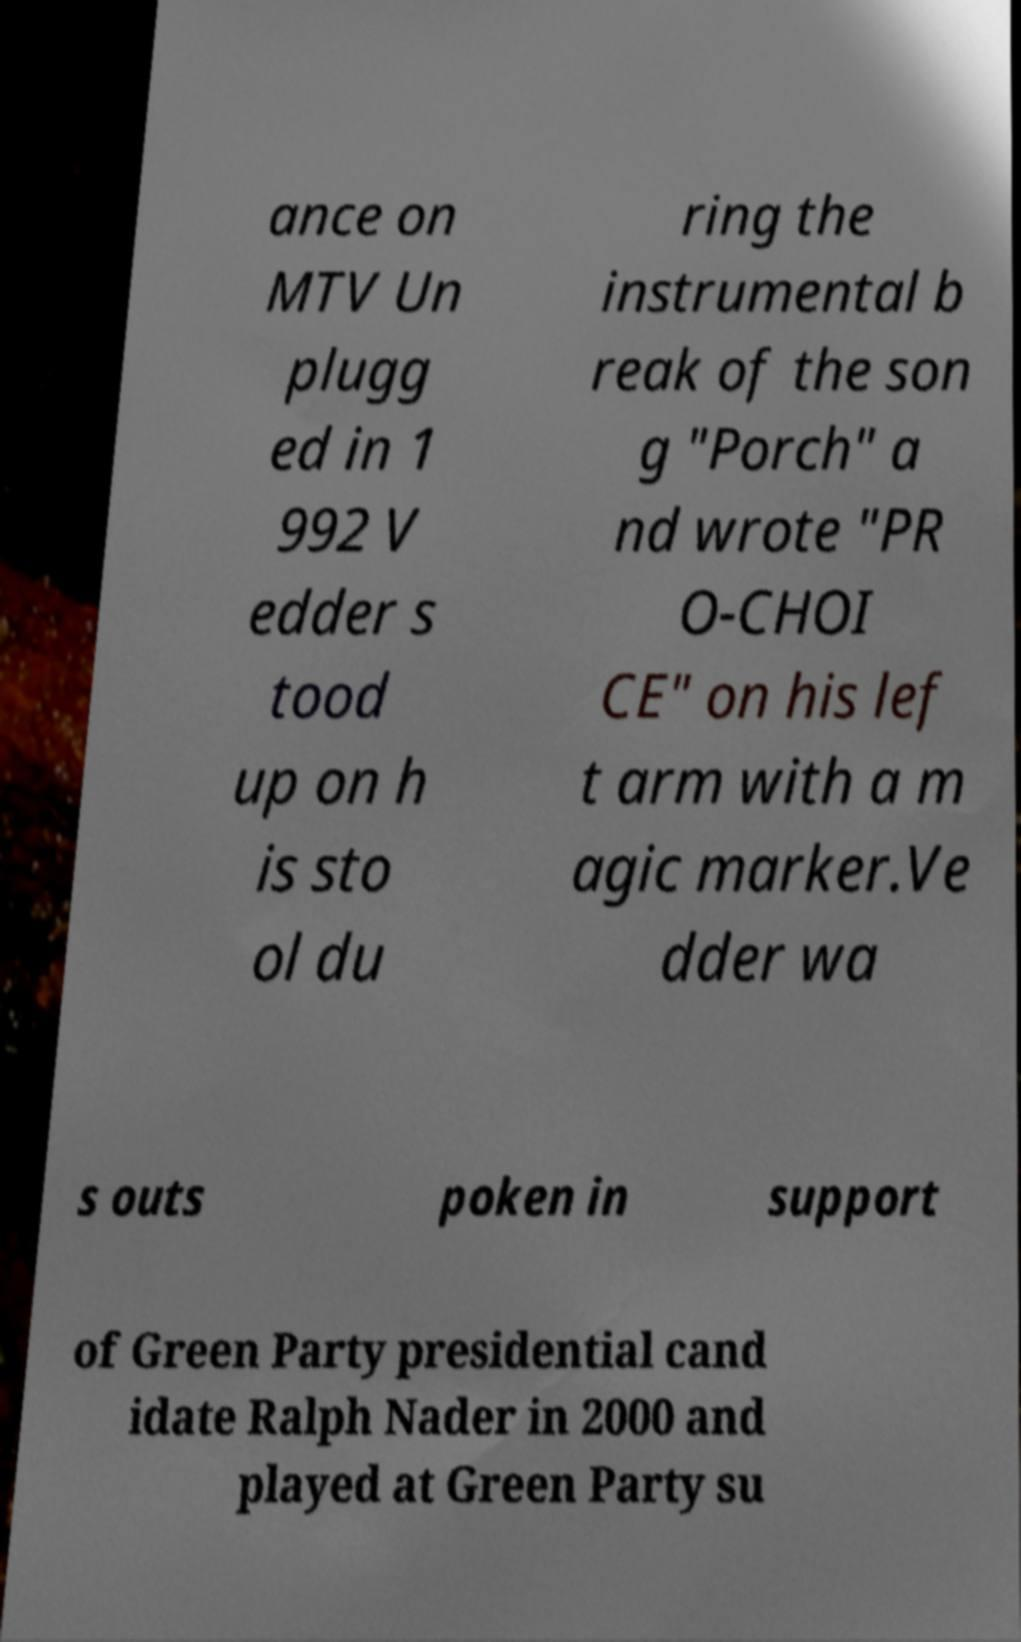I need the written content from this picture converted into text. Can you do that? ance on MTV Un plugg ed in 1 992 V edder s tood up on h is sto ol du ring the instrumental b reak of the son g "Porch" a nd wrote "PR O-CHOI CE" on his lef t arm with a m agic marker.Ve dder wa s outs poken in support of Green Party presidential cand idate Ralph Nader in 2000 and played at Green Party su 